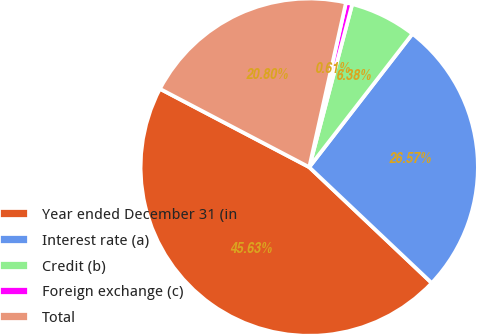<chart> <loc_0><loc_0><loc_500><loc_500><pie_chart><fcel>Year ended December 31 (in<fcel>Interest rate (a)<fcel>Credit (b)<fcel>Foreign exchange (c)<fcel>Total<nl><fcel>45.63%<fcel>26.57%<fcel>6.38%<fcel>0.61%<fcel>20.8%<nl></chart> 